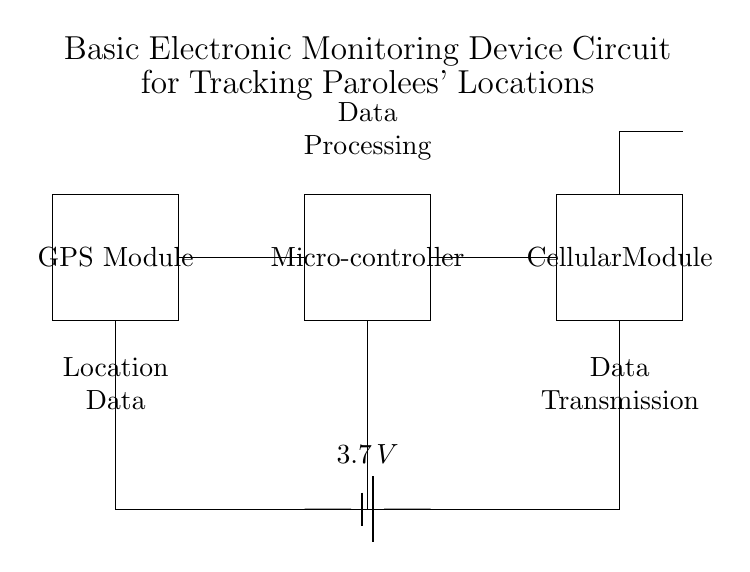What are the main components of this circuit? The circuit consists of a GPS Module, a Microcontroller, and a Cellular Module, as indicated by the labels on the rectangles.
Answer: GPS Module, Microcontroller, Cellular Module What is the voltage of the battery used in this device? The battery in the circuit is labeled as providing a voltage of 3.7 volts, which is shown next to the battery symbol.
Answer: 3.7 volts How does data processing occur in this device? The Microcontroller processes the data, as denoted by the label above the Microcontroller in the circuit. It receives data from the GPS Module and handles it before transmitting it.
Answer: Microcontroller What type of communication module is present in this circuit? The circuit includes a Cellular Module for data transmission, indicated by the label contained within the rectangle representing the module.
Answer: Cellular Module Which component is responsible for transmitting location data? The Cellular Module is responsible for transmitting the location data, as it is connected to the GPS Module and labeled as such in the circuit.
Answer: Cellular Module How is data transmitted from this device? The data is transmitted through an antenna connected to the Cellular Module, as shown by the line extending to the antenna symbol in the circuit diagram.
Answer: Antenna 